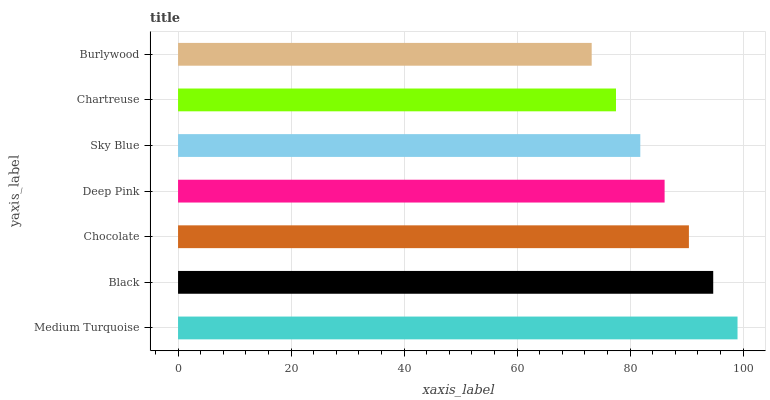Is Burlywood the minimum?
Answer yes or no. Yes. Is Medium Turquoise the maximum?
Answer yes or no. Yes. Is Black the minimum?
Answer yes or no. No. Is Black the maximum?
Answer yes or no. No. Is Medium Turquoise greater than Black?
Answer yes or no. Yes. Is Black less than Medium Turquoise?
Answer yes or no. Yes. Is Black greater than Medium Turquoise?
Answer yes or no. No. Is Medium Turquoise less than Black?
Answer yes or no. No. Is Deep Pink the high median?
Answer yes or no. Yes. Is Deep Pink the low median?
Answer yes or no. Yes. Is Sky Blue the high median?
Answer yes or no. No. Is Sky Blue the low median?
Answer yes or no. No. 